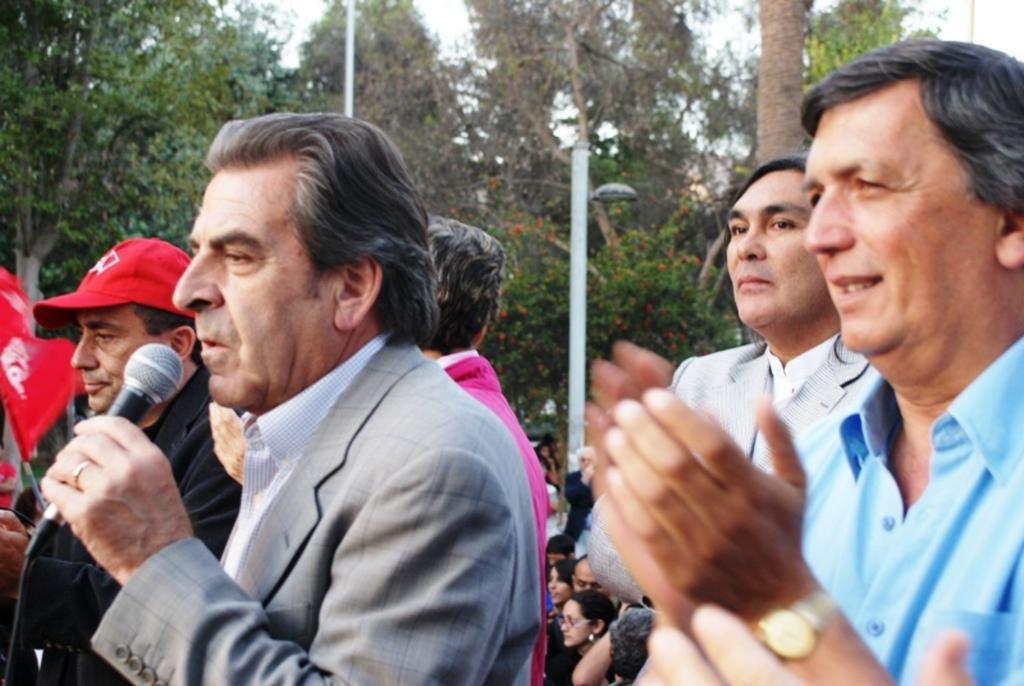Describe this image in one or two sentences. This is a picture taken in the outdoor, the man in grey blazer was holding a microphone and explaining something. Behind the man there are group of persons are standing. Background of this people is a pole and trees. 